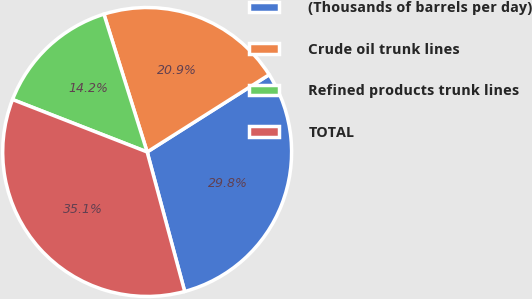Convert chart. <chart><loc_0><loc_0><loc_500><loc_500><pie_chart><fcel>(Thousands of barrels per day)<fcel>Crude oil trunk lines<fcel>Refined products trunk lines<fcel>TOTAL<nl><fcel>29.8%<fcel>20.85%<fcel>14.25%<fcel>35.1%<nl></chart> 